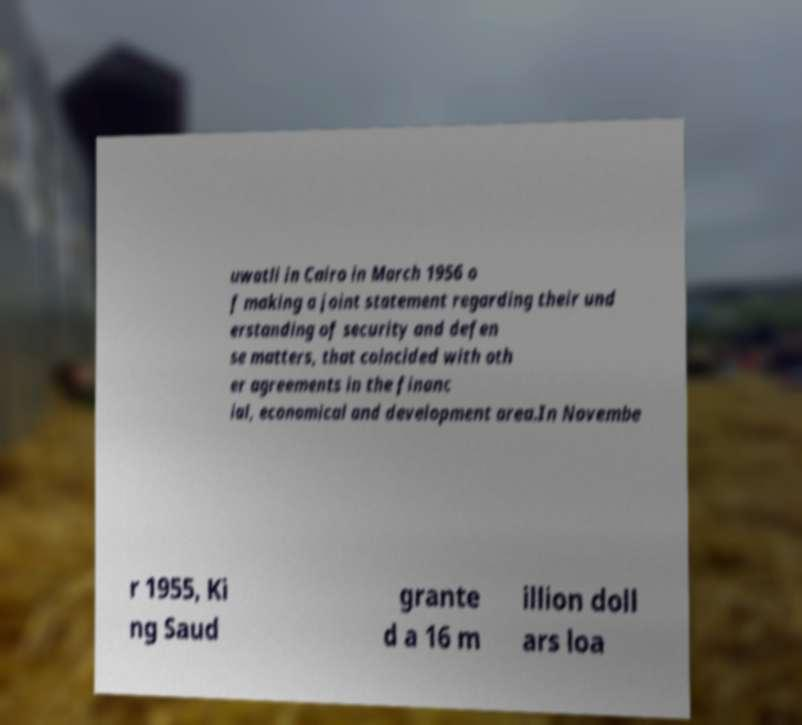Please read and relay the text visible in this image. What does it say? uwatli in Cairo in March 1956 o f making a joint statement regarding their und erstanding of security and defen se matters, that coincided with oth er agreements in the financ ial, economical and development area.In Novembe r 1955, Ki ng Saud grante d a 16 m illion doll ars loa 